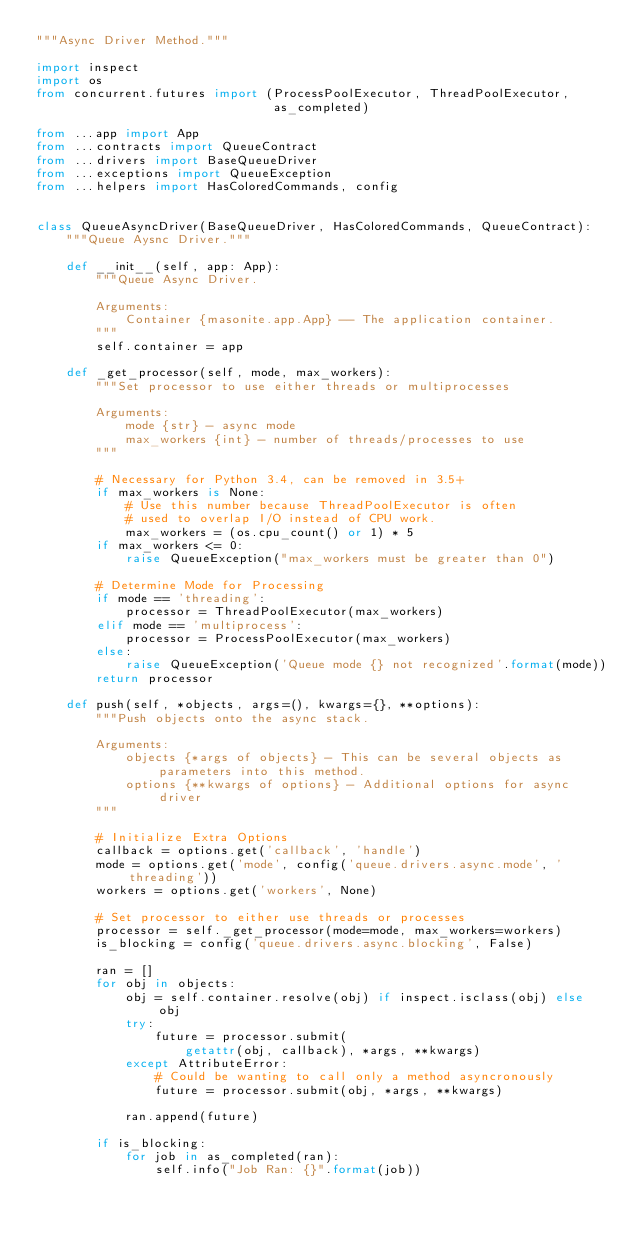<code> <loc_0><loc_0><loc_500><loc_500><_Python_>"""Async Driver Method."""

import inspect
import os
from concurrent.futures import (ProcessPoolExecutor, ThreadPoolExecutor,
                                as_completed)

from ...app import App
from ...contracts import QueueContract
from ...drivers import BaseQueueDriver
from ...exceptions import QueueException
from ...helpers import HasColoredCommands, config


class QueueAsyncDriver(BaseQueueDriver, HasColoredCommands, QueueContract):
    """Queue Aysnc Driver."""

    def __init__(self, app: App):
        """Queue Async Driver.

        Arguments:
            Container {masonite.app.App} -- The application container.
        """
        self.container = app

    def _get_processor(self, mode, max_workers):
        """Set processor to use either threads or multiprocesses

        Arguments:
            mode {str} - async mode
            max_workers {int} - number of threads/processes to use
        """

        # Necessary for Python 3.4, can be removed in 3.5+
        if max_workers is None:
            # Use this number because ThreadPoolExecutor is often
            # used to overlap I/O instead of CPU work.
            max_workers = (os.cpu_count() or 1) * 5
        if max_workers <= 0:
            raise QueueException("max_workers must be greater than 0")

        # Determine Mode for Processing
        if mode == 'threading':
            processor = ThreadPoolExecutor(max_workers)
        elif mode == 'multiprocess':
            processor = ProcessPoolExecutor(max_workers)
        else:
            raise QueueException('Queue mode {} not recognized'.format(mode))
        return processor

    def push(self, *objects, args=(), kwargs={}, **options):
        """Push objects onto the async stack.

        Arguments:
            objects {*args of objects} - This can be several objects as parameters into this method.
            options {**kwargs of options} - Additional options for async driver
        """

        # Initialize Extra Options
        callback = options.get('callback', 'handle')
        mode = options.get('mode', config('queue.drivers.async.mode', 'threading'))
        workers = options.get('workers', None)

        # Set processor to either use threads or processes
        processor = self._get_processor(mode=mode, max_workers=workers)
        is_blocking = config('queue.drivers.async.blocking', False)

        ran = []
        for obj in objects:
            obj = self.container.resolve(obj) if inspect.isclass(obj) else obj
            try:
                future = processor.submit(
                    getattr(obj, callback), *args, **kwargs)
            except AttributeError:
                # Could be wanting to call only a method asyncronously
                future = processor.submit(obj, *args, **kwargs)

            ran.append(future)

        if is_blocking:
            for job in as_completed(ran):
                self.info("Job Ran: {}".format(job))
</code> 